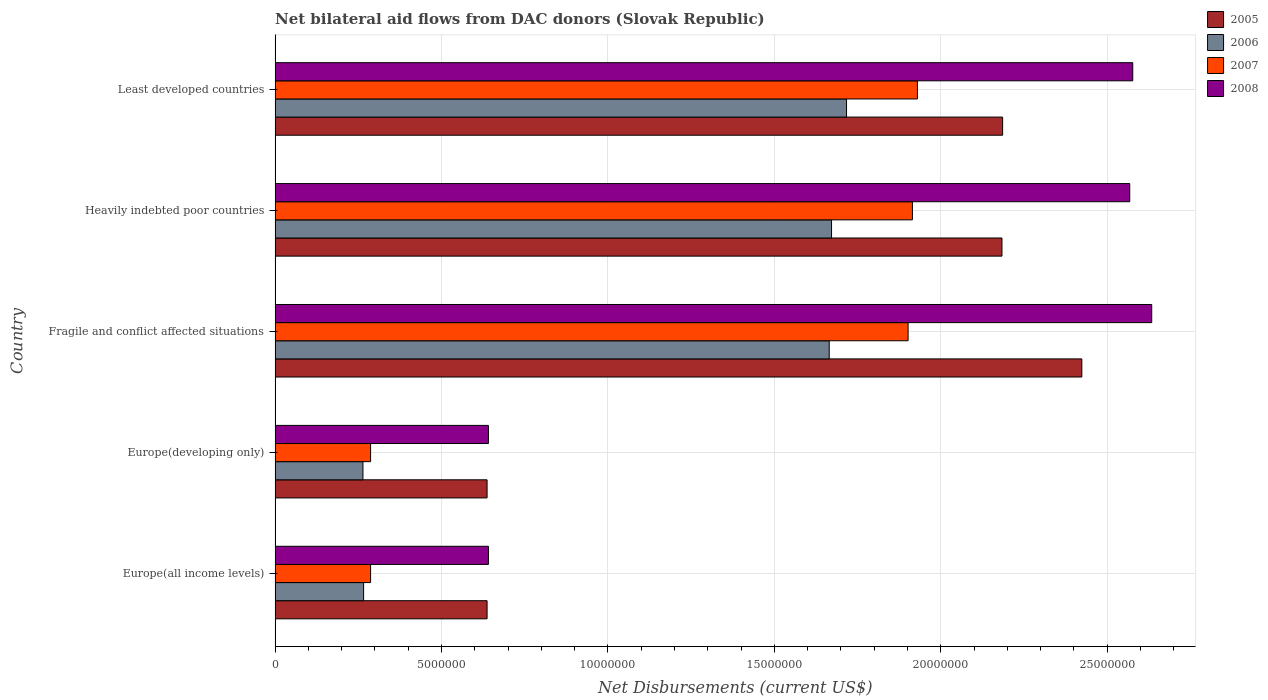How many groups of bars are there?
Give a very brief answer. 5. Are the number of bars per tick equal to the number of legend labels?
Offer a terse response. Yes. How many bars are there on the 4th tick from the top?
Your answer should be very brief. 4. How many bars are there on the 5th tick from the bottom?
Keep it short and to the point. 4. What is the label of the 1st group of bars from the top?
Your answer should be compact. Least developed countries. In how many cases, is the number of bars for a given country not equal to the number of legend labels?
Offer a terse response. 0. What is the net bilateral aid flows in 2006 in Heavily indebted poor countries?
Offer a terse response. 1.67e+07. Across all countries, what is the maximum net bilateral aid flows in 2006?
Provide a short and direct response. 1.72e+07. Across all countries, what is the minimum net bilateral aid flows in 2005?
Ensure brevity in your answer.  6.37e+06. In which country was the net bilateral aid flows in 2005 maximum?
Offer a terse response. Fragile and conflict affected situations. In which country was the net bilateral aid flows in 2005 minimum?
Make the answer very short. Europe(all income levels). What is the total net bilateral aid flows in 2005 in the graph?
Ensure brevity in your answer.  8.07e+07. What is the difference between the net bilateral aid flows in 2007 in Europe(developing only) and the net bilateral aid flows in 2008 in Least developed countries?
Keep it short and to the point. -2.29e+07. What is the average net bilateral aid flows in 2005 per country?
Provide a short and direct response. 1.61e+07. What is the difference between the net bilateral aid flows in 2005 and net bilateral aid flows in 2007 in Europe(developing only)?
Keep it short and to the point. 3.50e+06. What is the ratio of the net bilateral aid flows in 2008 in Europe(all income levels) to that in Heavily indebted poor countries?
Provide a succinct answer. 0.25. What is the difference between the highest and the second highest net bilateral aid flows in 2006?
Give a very brief answer. 4.50e+05. What is the difference between the highest and the lowest net bilateral aid flows in 2005?
Make the answer very short. 1.79e+07. What does the 2nd bar from the top in Fragile and conflict affected situations represents?
Keep it short and to the point. 2007. Is it the case that in every country, the sum of the net bilateral aid flows in 2007 and net bilateral aid flows in 2005 is greater than the net bilateral aid flows in 2008?
Keep it short and to the point. Yes. How many bars are there?
Your response must be concise. 20. Are all the bars in the graph horizontal?
Provide a succinct answer. Yes. How many countries are there in the graph?
Keep it short and to the point. 5. What is the difference between two consecutive major ticks on the X-axis?
Offer a very short reply. 5.00e+06. Does the graph contain grids?
Your answer should be very brief. Yes. How are the legend labels stacked?
Give a very brief answer. Vertical. What is the title of the graph?
Ensure brevity in your answer.  Net bilateral aid flows from DAC donors (Slovak Republic). What is the label or title of the X-axis?
Your answer should be very brief. Net Disbursements (current US$). What is the label or title of the Y-axis?
Your response must be concise. Country. What is the Net Disbursements (current US$) in 2005 in Europe(all income levels)?
Keep it short and to the point. 6.37e+06. What is the Net Disbursements (current US$) in 2006 in Europe(all income levels)?
Your answer should be compact. 2.66e+06. What is the Net Disbursements (current US$) in 2007 in Europe(all income levels)?
Provide a short and direct response. 2.87e+06. What is the Net Disbursements (current US$) of 2008 in Europe(all income levels)?
Offer a terse response. 6.41e+06. What is the Net Disbursements (current US$) in 2005 in Europe(developing only)?
Make the answer very short. 6.37e+06. What is the Net Disbursements (current US$) of 2006 in Europe(developing only)?
Offer a terse response. 2.64e+06. What is the Net Disbursements (current US$) of 2007 in Europe(developing only)?
Your response must be concise. 2.87e+06. What is the Net Disbursements (current US$) of 2008 in Europe(developing only)?
Provide a short and direct response. 6.41e+06. What is the Net Disbursements (current US$) in 2005 in Fragile and conflict affected situations?
Your answer should be very brief. 2.42e+07. What is the Net Disbursements (current US$) in 2006 in Fragile and conflict affected situations?
Your answer should be compact. 1.66e+07. What is the Net Disbursements (current US$) of 2007 in Fragile and conflict affected situations?
Provide a succinct answer. 1.90e+07. What is the Net Disbursements (current US$) in 2008 in Fragile and conflict affected situations?
Your answer should be compact. 2.63e+07. What is the Net Disbursements (current US$) of 2005 in Heavily indebted poor countries?
Your answer should be very brief. 2.18e+07. What is the Net Disbursements (current US$) of 2006 in Heavily indebted poor countries?
Your response must be concise. 1.67e+07. What is the Net Disbursements (current US$) in 2007 in Heavily indebted poor countries?
Your response must be concise. 1.92e+07. What is the Net Disbursements (current US$) in 2008 in Heavily indebted poor countries?
Give a very brief answer. 2.57e+07. What is the Net Disbursements (current US$) of 2005 in Least developed countries?
Keep it short and to the point. 2.19e+07. What is the Net Disbursements (current US$) of 2006 in Least developed countries?
Your answer should be compact. 1.72e+07. What is the Net Disbursements (current US$) in 2007 in Least developed countries?
Provide a short and direct response. 1.93e+07. What is the Net Disbursements (current US$) in 2008 in Least developed countries?
Ensure brevity in your answer.  2.58e+07. Across all countries, what is the maximum Net Disbursements (current US$) in 2005?
Your response must be concise. 2.42e+07. Across all countries, what is the maximum Net Disbursements (current US$) of 2006?
Provide a short and direct response. 1.72e+07. Across all countries, what is the maximum Net Disbursements (current US$) in 2007?
Ensure brevity in your answer.  1.93e+07. Across all countries, what is the maximum Net Disbursements (current US$) of 2008?
Offer a very short reply. 2.63e+07. Across all countries, what is the minimum Net Disbursements (current US$) in 2005?
Make the answer very short. 6.37e+06. Across all countries, what is the minimum Net Disbursements (current US$) of 2006?
Offer a very short reply. 2.64e+06. Across all countries, what is the minimum Net Disbursements (current US$) of 2007?
Keep it short and to the point. 2.87e+06. Across all countries, what is the minimum Net Disbursements (current US$) in 2008?
Make the answer very short. 6.41e+06. What is the total Net Disbursements (current US$) of 2005 in the graph?
Your answer should be compact. 8.07e+07. What is the total Net Disbursements (current US$) in 2006 in the graph?
Keep it short and to the point. 5.58e+07. What is the total Net Disbursements (current US$) in 2007 in the graph?
Keep it short and to the point. 6.32e+07. What is the total Net Disbursements (current US$) of 2008 in the graph?
Ensure brevity in your answer.  9.06e+07. What is the difference between the Net Disbursements (current US$) in 2005 in Europe(all income levels) and that in Europe(developing only)?
Your answer should be very brief. 0. What is the difference between the Net Disbursements (current US$) in 2006 in Europe(all income levels) and that in Europe(developing only)?
Your answer should be compact. 2.00e+04. What is the difference between the Net Disbursements (current US$) in 2005 in Europe(all income levels) and that in Fragile and conflict affected situations?
Ensure brevity in your answer.  -1.79e+07. What is the difference between the Net Disbursements (current US$) in 2006 in Europe(all income levels) and that in Fragile and conflict affected situations?
Keep it short and to the point. -1.40e+07. What is the difference between the Net Disbursements (current US$) in 2007 in Europe(all income levels) and that in Fragile and conflict affected situations?
Provide a succinct answer. -1.62e+07. What is the difference between the Net Disbursements (current US$) of 2008 in Europe(all income levels) and that in Fragile and conflict affected situations?
Make the answer very short. -1.99e+07. What is the difference between the Net Disbursements (current US$) in 2005 in Europe(all income levels) and that in Heavily indebted poor countries?
Your answer should be very brief. -1.55e+07. What is the difference between the Net Disbursements (current US$) of 2006 in Europe(all income levels) and that in Heavily indebted poor countries?
Offer a terse response. -1.41e+07. What is the difference between the Net Disbursements (current US$) of 2007 in Europe(all income levels) and that in Heavily indebted poor countries?
Your answer should be very brief. -1.63e+07. What is the difference between the Net Disbursements (current US$) of 2008 in Europe(all income levels) and that in Heavily indebted poor countries?
Offer a terse response. -1.93e+07. What is the difference between the Net Disbursements (current US$) in 2005 in Europe(all income levels) and that in Least developed countries?
Ensure brevity in your answer.  -1.55e+07. What is the difference between the Net Disbursements (current US$) in 2006 in Europe(all income levels) and that in Least developed countries?
Keep it short and to the point. -1.45e+07. What is the difference between the Net Disbursements (current US$) in 2007 in Europe(all income levels) and that in Least developed countries?
Provide a succinct answer. -1.64e+07. What is the difference between the Net Disbursements (current US$) in 2008 in Europe(all income levels) and that in Least developed countries?
Your response must be concise. -1.94e+07. What is the difference between the Net Disbursements (current US$) in 2005 in Europe(developing only) and that in Fragile and conflict affected situations?
Provide a short and direct response. -1.79e+07. What is the difference between the Net Disbursements (current US$) of 2006 in Europe(developing only) and that in Fragile and conflict affected situations?
Make the answer very short. -1.40e+07. What is the difference between the Net Disbursements (current US$) in 2007 in Europe(developing only) and that in Fragile and conflict affected situations?
Your answer should be very brief. -1.62e+07. What is the difference between the Net Disbursements (current US$) in 2008 in Europe(developing only) and that in Fragile and conflict affected situations?
Your response must be concise. -1.99e+07. What is the difference between the Net Disbursements (current US$) of 2005 in Europe(developing only) and that in Heavily indebted poor countries?
Make the answer very short. -1.55e+07. What is the difference between the Net Disbursements (current US$) in 2006 in Europe(developing only) and that in Heavily indebted poor countries?
Your answer should be compact. -1.41e+07. What is the difference between the Net Disbursements (current US$) in 2007 in Europe(developing only) and that in Heavily indebted poor countries?
Provide a short and direct response. -1.63e+07. What is the difference between the Net Disbursements (current US$) in 2008 in Europe(developing only) and that in Heavily indebted poor countries?
Provide a short and direct response. -1.93e+07. What is the difference between the Net Disbursements (current US$) of 2005 in Europe(developing only) and that in Least developed countries?
Your answer should be compact. -1.55e+07. What is the difference between the Net Disbursements (current US$) in 2006 in Europe(developing only) and that in Least developed countries?
Offer a terse response. -1.45e+07. What is the difference between the Net Disbursements (current US$) in 2007 in Europe(developing only) and that in Least developed countries?
Give a very brief answer. -1.64e+07. What is the difference between the Net Disbursements (current US$) of 2008 in Europe(developing only) and that in Least developed countries?
Your answer should be compact. -1.94e+07. What is the difference between the Net Disbursements (current US$) of 2005 in Fragile and conflict affected situations and that in Heavily indebted poor countries?
Provide a succinct answer. 2.40e+06. What is the difference between the Net Disbursements (current US$) in 2005 in Fragile and conflict affected situations and that in Least developed countries?
Offer a terse response. 2.38e+06. What is the difference between the Net Disbursements (current US$) in 2006 in Fragile and conflict affected situations and that in Least developed countries?
Offer a very short reply. -5.20e+05. What is the difference between the Net Disbursements (current US$) of 2007 in Fragile and conflict affected situations and that in Least developed countries?
Give a very brief answer. -2.80e+05. What is the difference between the Net Disbursements (current US$) in 2008 in Fragile and conflict affected situations and that in Least developed countries?
Your answer should be compact. 5.70e+05. What is the difference between the Net Disbursements (current US$) in 2006 in Heavily indebted poor countries and that in Least developed countries?
Keep it short and to the point. -4.50e+05. What is the difference between the Net Disbursements (current US$) of 2008 in Heavily indebted poor countries and that in Least developed countries?
Offer a very short reply. -9.00e+04. What is the difference between the Net Disbursements (current US$) of 2005 in Europe(all income levels) and the Net Disbursements (current US$) of 2006 in Europe(developing only)?
Ensure brevity in your answer.  3.73e+06. What is the difference between the Net Disbursements (current US$) of 2005 in Europe(all income levels) and the Net Disbursements (current US$) of 2007 in Europe(developing only)?
Your answer should be compact. 3.50e+06. What is the difference between the Net Disbursements (current US$) in 2006 in Europe(all income levels) and the Net Disbursements (current US$) in 2008 in Europe(developing only)?
Ensure brevity in your answer.  -3.75e+06. What is the difference between the Net Disbursements (current US$) in 2007 in Europe(all income levels) and the Net Disbursements (current US$) in 2008 in Europe(developing only)?
Your answer should be compact. -3.54e+06. What is the difference between the Net Disbursements (current US$) of 2005 in Europe(all income levels) and the Net Disbursements (current US$) of 2006 in Fragile and conflict affected situations?
Keep it short and to the point. -1.03e+07. What is the difference between the Net Disbursements (current US$) in 2005 in Europe(all income levels) and the Net Disbursements (current US$) in 2007 in Fragile and conflict affected situations?
Ensure brevity in your answer.  -1.26e+07. What is the difference between the Net Disbursements (current US$) in 2005 in Europe(all income levels) and the Net Disbursements (current US$) in 2008 in Fragile and conflict affected situations?
Provide a short and direct response. -2.00e+07. What is the difference between the Net Disbursements (current US$) of 2006 in Europe(all income levels) and the Net Disbursements (current US$) of 2007 in Fragile and conflict affected situations?
Your response must be concise. -1.64e+07. What is the difference between the Net Disbursements (current US$) of 2006 in Europe(all income levels) and the Net Disbursements (current US$) of 2008 in Fragile and conflict affected situations?
Provide a succinct answer. -2.37e+07. What is the difference between the Net Disbursements (current US$) in 2007 in Europe(all income levels) and the Net Disbursements (current US$) in 2008 in Fragile and conflict affected situations?
Give a very brief answer. -2.35e+07. What is the difference between the Net Disbursements (current US$) in 2005 in Europe(all income levels) and the Net Disbursements (current US$) in 2006 in Heavily indebted poor countries?
Provide a short and direct response. -1.04e+07. What is the difference between the Net Disbursements (current US$) in 2005 in Europe(all income levels) and the Net Disbursements (current US$) in 2007 in Heavily indebted poor countries?
Provide a short and direct response. -1.28e+07. What is the difference between the Net Disbursements (current US$) of 2005 in Europe(all income levels) and the Net Disbursements (current US$) of 2008 in Heavily indebted poor countries?
Your answer should be compact. -1.93e+07. What is the difference between the Net Disbursements (current US$) of 2006 in Europe(all income levels) and the Net Disbursements (current US$) of 2007 in Heavily indebted poor countries?
Your answer should be compact. -1.65e+07. What is the difference between the Net Disbursements (current US$) of 2006 in Europe(all income levels) and the Net Disbursements (current US$) of 2008 in Heavily indebted poor countries?
Give a very brief answer. -2.30e+07. What is the difference between the Net Disbursements (current US$) of 2007 in Europe(all income levels) and the Net Disbursements (current US$) of 2008 in Heavily indebted poor countries?
Your answer should be compact. -2.28e+07. What is the difference between the Net Disbursements (current US$) in 2005 in Europe(all income levels) and the Net Disbursements (current US$) in 2006 in Least developed countries?
Give a very brief answer. -1.08e+07. What is the difference between the Net Disbursements (current US$) of 2005 in Europe(all income levels) and the Net Disbursements (current US$) of 2007 in Least developed countries?
Offer a very short reply. -1.29e+07. What is the difference between the Net Disbursements (current US$) in 2005 in Europe(all income levels) and the Net Disbursements (current US$) in 2008 in Least developed countries?
Your response must be concise. -1.94e+07. What is the difference between the Net Disbursements (current US$) in 2006 in Europe(all income levels) and the Net Disbursements (current US$) in 2007 in Least developed countries?
Provide a succinct answer. -1.66e+07. What is the difference between the Net Disbursements (current US$) in 2006 in Europe(all income levels) and the Net Disbursements (current US$) in 2008 in Least developed countries?
Offer a terse response. -2.31e+07. What is the difference between the Net Disbursements (current US$) in 2007 in Europe(all income levels) and the Net Disbursements (current US$) in 2008 in Least developed countries?
Give a very brief answer. -2.29e+07. What is the difference between the Net Disbursements (current US$) in 2005 in Europe(developing only) and the Net Disbursements (current US$) in 2006 in Fragile and conflict affected situations?
Provide a succinct answer. -1.03e+07. What is the difference between the Net Disbursements (current US$) of 2005 in Europe(developing only) and the Net Disbursements (current US$) of 2007 in Fragile and conflict affected situations?
Offer a very short reply. -1.26e+07. What is the difference between the Net Disbursements (current US$) in 2005 in Europe(developing only) and the Net Disbursements (current US$) in 2008 in Fragile and conflict affected situations?
Your answer should be compact. -2.00e+07. What is the difference between the Net Disbursements (current US$) in 2006 in Europe(developing only) and the Net Disbursements (current US$) in 2007 in Fragile and conflict affected situations?
Provide a short and direct response. -1.64e+07. What is the difference between the Net Disbursements (current US$) of 2006 in Europe(developing only) and the Net Disbursements (current US$) of 2008 in Fragile and conflict affected situations?
Provide a succinct answer. -2.37e+07. What is the difference between the Net Disbursements (current US$) in 2007 in Europe(developing only) and the Net Disbursements (current US$) in 2008 in Fragile and conflict affected situations?
Your response must be concise. -2.35e+07. What is the difference between the Net Disbursements (current US$) of 2005 in Europe(developing only) and the Net Disbursements (current US$) of 2006 in Heavily indebted poor countries?
Offer a terse response. -1.04e+07. What is the difference between the Net Disbursements (current US$) of 2005 in Europe(developing only) and the Net Disbursements (current US$) of 2007 in Heavily indebted poor countries?
Offer a very short reply. -1.28e+07. What is the difference between the Net Disbursements (current US$) of 2005 in Europe(developing only) and the Net Disbursements (current US$) of 2008 in Heavily indebted poor countries?
Make the answer very short. -1.93e+07. What is the difference between the Net Disbursements (current US$) of 2006 in Europe(developing only) and the Net Disbursements (current US$) of 2007 in Heavily indebted poor countries?
Make the answer very short. -1.65e+07. What is the difference between the Net Disbursements (current US$) of 2006 in Europe(developing only) and the Net Disbursements (current US$) of 2008 in Heavily indebted poor countries?
Ensure brevity in your answer.  -2.30e+07. What is the difference between the Net Disbursements (current US$) in 2007 in Europe(developing only) and the Net Disbursements (current US$) in 2008 in Heavily indebted poor countries?
Your response must be concise. -2.28e+07. What is the difference between the Net Disbursements (current US$) in 2005 in Europe(developing only) and the Net Disbursements (current US$) in 2006 in Least developed countries?
Make the answer very short. -1.08e+07. What is the difference between the Net Disbursements (current US$) in 2005 in Europe(developing only) and the Net Disbursements (current US$) in 2007 in Least developed countries?
Provide a short and direct response. -1.29e+07. What is the difference between the Net Disbursements (current US$) in 2005 in Europe(developing only) and the Net Disbursements (current US$) in 2008 in Least developed countries?
Your answer should be compact. -1.94e+07. What is the difference between the Net Disbursements (current US$) of 2006 in Europe(developing only) and the Net Disbursements (current US$) of 2007 in Least developed countries?
Provide a succinct answer. -1.67e+07. What is the difference between the Net Disbursements (current US$) of 2006 in Europe(developing only) and the Net Disbursements (current US$) of 2008 in Least developed countries?
Give a very brief answer. -2.31e+07. What is the difference between the Net Disbursements (current US$) of 2007 in Europe(developing only) and the Net Disbursements (current US$) of 2008 in Least developed countries?
Make the answer very short. -2.29e+07. What is the difference between the Net Disbursements (current US$) in 2005 in Fragile and conflict affected situations and the Net Disbursements (current US$) in 2006 in Heavily indebted poor countries?
Your answer should be very brief. 7.52e+06. What is the difference between the Net Disbursements (current US$) of 2005 in Fragile and conflict affected situations and the Net Disbursements (current US$) of 2007 in Heavily indebted poor countries?
Make the answer very short. 5.09e+06. What is the difference between the Net Disbursements (current US$) in 2005 in Fragile and conflict affected situations and the Net Disbursements (current US$) in 2008 in Heavily indebted poor countries?
Offer a terse response. -1.44e+06. What is the difference between the Net Disbursements (current US$) in 2006 in Fragile and conflict affected situations and the Net Disbursements (current US$) in 2007 in Heavily indebted poor countries?
Provide a succinct answer. -2.50e+06. What is the difference between the Net Disbursements (current US$) of 2006 in Fragile and conflict affected situations and the Net Disbursements (current US$) of 2008 in Heavily indebted poor countries?
Provide a short and direct response. -9.03e+06. What is the difference between the Net Disbursements (current US$) of 2007 in Fragile and conflict affected situations and the Net Disbursements (current US$) of 2008 in Heavily indebted poor countries?
Your answer should be compact. -6.66e+06. What is the difference between the Net Disbursements (current US$) in 2005 in Fragile and conflict affected situations and the Net Disbursements (current US$) in 2006 in Least developed countries?
Provide a short and direct response. 7.07e+06. What is the difference between the Net Disbursements (current US$) in 2005 in Fragile and conflict affected situations and the Net Disbursements (current US$) in 2007 in Least developed countries?
Make the answer very short. 4.94e+06. What is the difference between the Net Disbursements (current US$) in 2005 in Fragile and conflict affected situations and the Net Disbursements (current US$) in 2008 in Least developed countries?
Provide a succinct answer. -1.53e+06. What is the difference between the Net Disbursements (current US$) in 2006 in Fragile and conflict affected situations and the Net Disbursements (current US$) in 2007 in Least developed countries?
Provide a succinct answer. -2.65e+06. What is the difference between the Net Disbursements (current US$) of 2006 in Fragile and conflict affected situations and the Net Disbursements (current US$) of 2008 in Least developed countries?
Make the answer very short. -9.12e+06. What is the difference between the Net Disbursements (current US$) in 2007 in Fragile and conflict affected situations and the Net Disbursements (current US$) in 2008 in Least developed countries?
Make the answer very short. -6.75e+06. What is the difference between the Net Disbursements (current US$) in 2005 in Heavily indebted poor countries and the Net Disbursements (current US$) in 2006 in Least developed countries?
Offer a very short reply. 4.67e+06. What is the difference between the Net Disbursements (current US$) of 2005 in Heavily indebted poor countries and the Net Disbursements (current US$) of 2007 in Least developed countries?
Your answer should be compact. 2.54e+06. What is the difference between the Net Disbursements (current US$) of 2005 in Heavily indebted poor countries and the Net Disbursements (current US$) of 2008 in Least developed countries?
Your answer should be compact. -3.93e+06. What is the difference between the Net Disbursements (current US$) in 2006 in Heavily indebted poor countries and the Net Disbursements (current US$) in 2007 in Least developed countries?
Give a very brief answer. -2.58e+06. What is the difference between the Net Disbursements (current US$) in 2006 in Heavily indebted poor countries and the Net Disbursements (current US$) in 2008 in Least developed countries?
Keep it short and to the point. -9.05e+06. What is the difference between the Net Disbursements (current US$) of 2007 in Heavily indebted poor countries and the Net Disbursements (current US$) of 2008 in Least developed countries?
Your answer should be very brief. -6.62e+06. What is the average Net Disbursements (current US$) in 2005 per country?
Provide a short and direct response. 1.61e+07. What is the average Net Disbursements (current US$) of 2006 per country?
Your response must be concise. 1.12e+07. What is the average Net Disbursements (current US$) of 2007 per country?
Your answer should be very brief. 1.26e+07. What is the average Net Disbursements (current US$) in 2008 per country?
Give a very brief answer. 1.81e+07. What is the difference between the Net Disbursements (current US$) of 2005 and Net Disbursements (current US$) of 2006 in Europe(all income levels)?
Your answer should be compact. 3.71e+06. What is the difference between the Net Disbursements (current US$) of 2005 and Net Disbursements (current US$) of 2007 in Europe(all income levels)?
Offer a terse response. 3.50e+06. What is the difference between the Net Disbursements (current US$) in 2005 and Net Disbursements (current US$) in 2008 in Europe(all income levels)?
Provide a short and direct response. -4.00e+04. What is the difference between the Net Disbursements (current US$) of 2006 and Net Disbursements (current US$) of 2007 in Europe(all income levels)?
Your answer should be compact. -2.10e+05. What is the difference between the Net Disbursements (current US$) in 2006 and Net Disbursements (current US$) in 2008 in Europe(all income levels)?
Your answer should be very brief. -3.75e+06. What is the difference between the Net Disbursements (current US$) in 2007 and Net Disbursements (current US$) in 2008 in Europe(all income levels)?
Your response must be concise. -3.54e+06. What is the difference between the Net Disbursements (current US$) of 2005 and Net Disbursements (current US$) of 2006 in Europe(developing only)?
Ensure brevity in your answer.  3.73e+06. What is the difference between the Net Disbursements (current US$) in 2005 and Net Disbursements (current US$) in 2007 in Europe(developing only)?
Your answer should be compact. 3.50e+06. What is the difference between the Net Disbursements (current US$) of 2005 and Net Disbursements (current US$) of 2008 in Europe(developing only)?
Provide a short and direct response. -4.00e+04. What is the difference between the Net Disbursements (current US$) in 2006 and Net Disbursements (current US$) in 2007 in Europe(developing only)?
Offer a very short reply. -2.30e+05. What is the difference between the Net Disbursements (current US$) in 2006 and Net Disbursements (current US$) in 2008 in Europe(developing only)?
Give a very brief answer. -3.77e+06. What is the difference between the Net Disbursements (current US$) of 2007 and Net Disbursements (current US$) of 2008 in Europe(developing only)?
Offer a terse response. -3.54e+06. What is the difference between the Net Disbursements (current US$) in 2005 and Net Disbursements (current US$) in 2006 in Fragile and conflict affected situations?
Keep it short and to the point. 7.59e+06. What is the difference between the Net Disbursements (current US$) in 2005 and Net Disbursements (current US$) in 2007 in Fragile and conflict affected situations?
Ensure brevity in your answer.  5.22e+06. What is the difference between the Net Disbursements (current US$) of 2005 and Net Disbursements (current US$) of 2008 in Fragile and conflict affected situations?
Offer a terse response. -2.10e+06. What is the difference between the Net Disbursements (current US$) of 2006 and Net Disbursements (current US$) of 2007 in Fragile and conflict affected situations?
Provide a short and direct response. -2.37e+06. What is the difference between the Net Disbursements (current US$) in 2006 and Net Disbursements (current US$) in 2008 in Fragile and conflict affected situations?
Offer a very short reply. -9.69e+06. What is the difference between the Net Disbursements (current US$) of 2007 and Net Disbursements (current US$) of 2008 in Fragile and conflict affected situations?
Provide a succinct answer. -7.32e+06. What is the difference between the Net Disbursements (current US$) in 2005 and Net Disbursements (current US$) in 2006 in Heavily indebted poor countries?
Give a very brief answer. 5.12e+06. What is the difference between the Net Disbursements (current US$) of 2005 and Net Disbursements (current US$) of 2007 in Heavily indebted poor countries?
Make the answer very short. 2.69e+06. What is the difference between the Net Disbursements (current US$) in 2005 and Net Disbursements (current US$) in 2008 in Heavily indebted poor countries?
Give a very brief answer. -3.84e+06. What is the difference between the Net Disbursements (current US$) of 2006 and Net Disbursements (current US$) of 2007 in Heavily indebted poor countries?
Keep it short and to the point. -2.43e+06. What is the difference between the Net Disbursements (current US$) of 2006 and Net Disbursements (current US$) of 2008 in Heavily indebted poor countries?
Ensure brevity in your answer.  -8.96e+06. What is the difference between the Net Disbursements (current US$) of 2007 and Net Disbursements (current US$) of 2008 in Heavily indebted poor countries?
Your answer should be compact. -6.53e+06. What is the difference between the Net Disbursements (current US$) in 2005 and Net Disbursements (current US$) in 2006 in Least developed countries?
Give a very brief answer. 4.69e+06. What is the difference between the Net Disbursements (current US$) in 2005 and Net Disbursements (current US$) in 2007 in Least developed countries?
Offer a very short reply. 2.56e+06. What is the difference between the Net Disbursements (current US$) in 2005 and Net Disbursements (current US$) in 2008 in Least developed countries?
Your answer should be very brief. -3.91e+06. What is the difference between the Net Disbursements (current US$) of 2006 and Net Disbursements (current US$) of 2007 in Least developed countries?
Provide a succinct answer. -2.13e+06. What is the difference between the Net Disbursements (current US$) in 2006 and Net Disbursements (current US$) in 2008 in Least developed countries?
Provide a short and direct response. -8.60e+06. What is the difference between the Net Disbursements (current US$) of 2007 and Net Disbursements (current US$) of 2008 in Least developed countries?
Provide a short and direct response. -6.47e+06. What is the ratio of the Net Disbursements (current US$) of 2006 in Europe(all income levels) to that in Europe(developing only)?
Provide a succinct answer. 1.01. What is the ratio of the Net Disbursements (current US$) of 2005 in Europe(all income levels) to that in Fragile and conflict affected situations?
Provide a succinct answer. 0.26. What is the ratio of the Net Disbursements (current US$) in 2006 in Europe(all income levels) to that in Fragile and conflict affected situations?
Provide a short and direct response. 0.16. What is the ratio of the Net Disbursements (current US$) in 2007 in Europe(all income levels) to that in Fragile and conflict affected situations?
Provide a succinct answer. 0.15. What is the ratio of the Net Disbursements (current US$) in 2008 in Europe(all income levels) to that in Fragile and conflict affected situations?
Your response must be concise. 0.24. What is the ratio of the Net Disbursements (current US$) in 2005 in Europe(all income levels) to that in Heavily indebted poor countries?
Offer a very short reply. 0.29. What is the ratio of the Net Disbursements (current US$) in 2006 in Europe(all income levels) to that in Heavily indebted poor countries?
Your answer should be very brief. 0.16. What is the ratio of the Net Disbursements (current US$) in 2007 in Europe(all income levels) to that in Heavily indebted poor countries?
Provide a short and direct response. 0.15. What is the ratio of the Net Disbursements (current US$) in 2008 in Europe(all income levels) to that in Heavily indebted poor countries?
Your answer should be very brief. 0.25. What is the ratio of the Net Disbursements (current US$) of 2005 in Europe(all income levels) to that in Least developed countries?
Your answer should be compact. 0.29. What is the ratio of the Net Disbursements (current US$) in 2006 in Europe(all income levels) to that in Least developed countries?
Make the answer very short. 0.15. What is the ratio of the Net Disbursements (current US$) in 2007 in Europe(all income levels) to that in Least developed countries?
Offer a terse response. 0.15. What is the ratio of the Net Disbursements (current US$) of 2008 in Europe(all income levels) to that in Least developed countries?
Offer a very short reply. 0.25. What is the ratio of the Net Disbursements (current US$) of 2005 in Europe(developing only) to that in Fragile and conflict affected situations?
Provide a short and direct response. 0.26. What is the ratio of the Net Disbursements (current US$) in 2006 in Europe(developing only) to that in Fragile and conflict affected situations?
Offer a very short reply. 0.16. What is the ratio of the Net Disbursements (current US$) of 2007 in Europe(developing only) to that in Fragile and conflict affected situations?
Provide a succinct answer. 0.15. What is the ratio of the Net Disbursements (current US$) in 2008 in Europe(developing only) to that in Fragile and conflict affected situations?
Offer a terse response. 0.24. What is the ratio of the Net Disbursements (current US$) in 2005 in Europe(developing only) to that in Heavily indebted poor countries?
Provide a short and direct response. 0.29. What is the ratio of the Net Disbursements (current US$) of 2006 in Europe(developing only) to that in Heavily indebted poor countries?
Your answer should be compact. 0.16. What is the ratio of the Net Disbursements (current US$) of 2007 in Europe(developing only) to that in Heavily indebted poor countries?
Ensure brevity in your answer.  0.15. What is the ratio of the Net Disbursements (current US$) of 2008 in Europe(developing only) to that in Heavily indebted poor countries?
Make the answer very short. 0.25. What is the ratio of the Net Disbursements (current US$) in 2005 in Europe(developing only) to that in Least developed countries?
Provide a short and direct response. 0.29. What is the ratio of the Net Disbursements (current US$) of 2006 in Europe(developing only) to that in Least developed countries?
Give a very brief answer. 0.15. What is the ratio of the Net Disbursements (current US$) of 2007 in Europe(developing only) to that in Least developed countries?
Provide a short and direct response. 0.15. What is the ratio of the Net Disbursements (current US$) of 2008 in Europe(developing only) to that in Least developed countries?
Make the answer very short. 0.25. What is the ratio of the Net Disbursements (current US$) in 2005 in Fragile and conflict affected situations to that in Heavily indebted poor countries?
Offer a terse response. 1.11. What is the ratio of the Net Disbursements (current US$) in 2007 in Fragile and conflict affected situations to that in Heavily indebted poor countries?
Make the answer very short. 0.99. What is the ratio of the Net Disbursements (current US$) of 2008 in Fragile and conflict affected situations to that in Heavily indebted poor countries?
Ensure brevity in your answer.  1.03. What is the ratio of the Net Disbursements (current US$) of 2005 in Fragile and conflict affected situations to that in Least developed countries?
Your answer should be very brief. 1.11. What is the ratio of the Net Disbursements (current US$) of 2006 in Fragile and conflict affected situations to that in Least developed countries?
Offer a terse response. 0.97. What is the ratio of the Net Disbursements (current US$) of 2007 in Fragile and conflict affected situations to that in Least developed countries?
Offer a very short reply. 0.99. What is the ratio of the Net Disbursements (current US$) in 2008 in Fragile and conflict affected situations to that in Least developed countries?
Your answer should be very brief. 1.02. What is the ratio of the Net Disbursements (current US$) of 2006 in Heavily indebted poor countries to that in Least developed countries?
Offer a terse response. 0.97. What is the ratio of the Net Disbursements (current US$) in 2007 in Heavily indebted poor countries to that in Least developed countries?
Provide a short and direct response. 0.99. What is the ratio of the Net Disbursements (current US$) in 2008 in Heavily indebted poor countries to that in Least developed countries?
Give a very brief answer. 1. What is the difference between the highest and the second highest Net Disbursements (current US$) in 2005?
Your answer should be very brief. 2.38e+06. What is the difference between the highest and the second highest Net Disbursements (current US$) in 2007?
Provide a succinct answer. 1.50e+05. What is the difference between the highest and the second highest Net Disbursements (current US$) in 2008?
Make the answer very short. 5.70e+05. What is the difference between the highest and the lowest Net Disbursements (current US$) of 2005?
Offer a terse response. 1.79e+07. What is the difference between the highest and the lowest Net Disbursements (current US$) of 2006?
Provide a succinct answer. 1.45e+07. What is the difference between the highest and the lowest Net Disbursements (current US$) in 2007?
Give a very brief answer. 1.64e+07. What is the difference between the highest and the lowest Net Disbursements (current US$) of 2008?
Provide a succinct answer. 1.99e+07. 